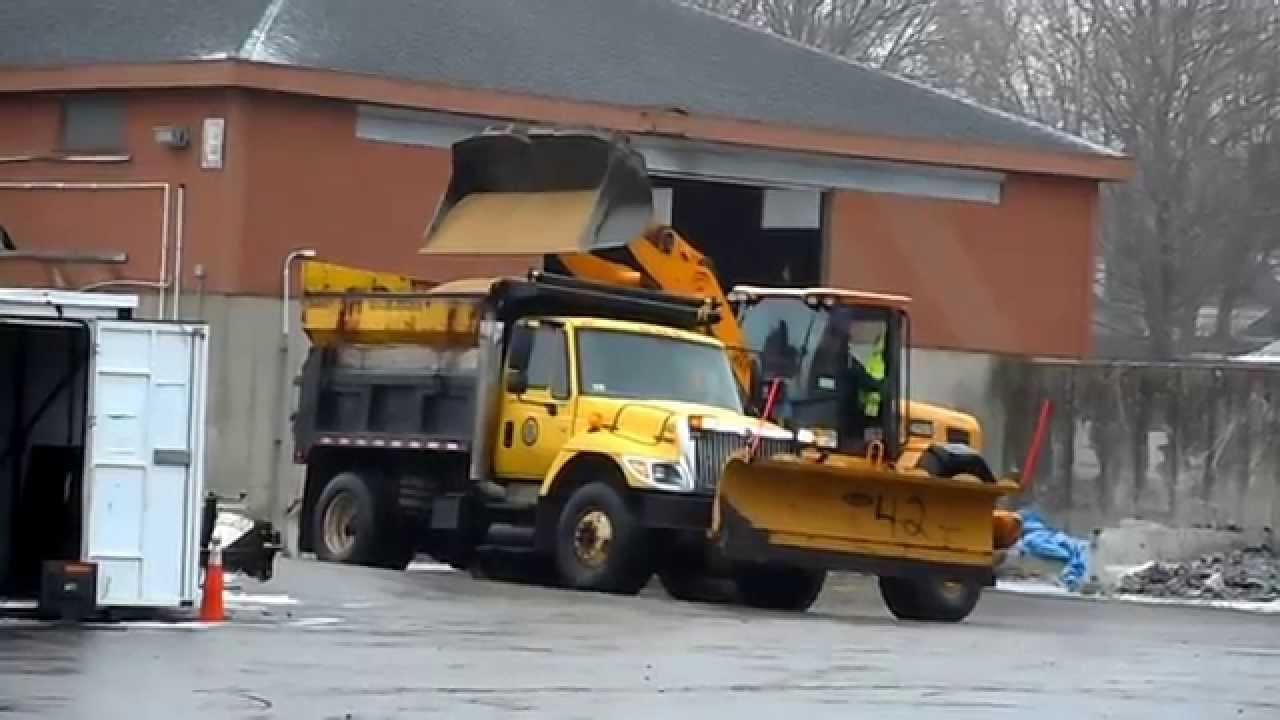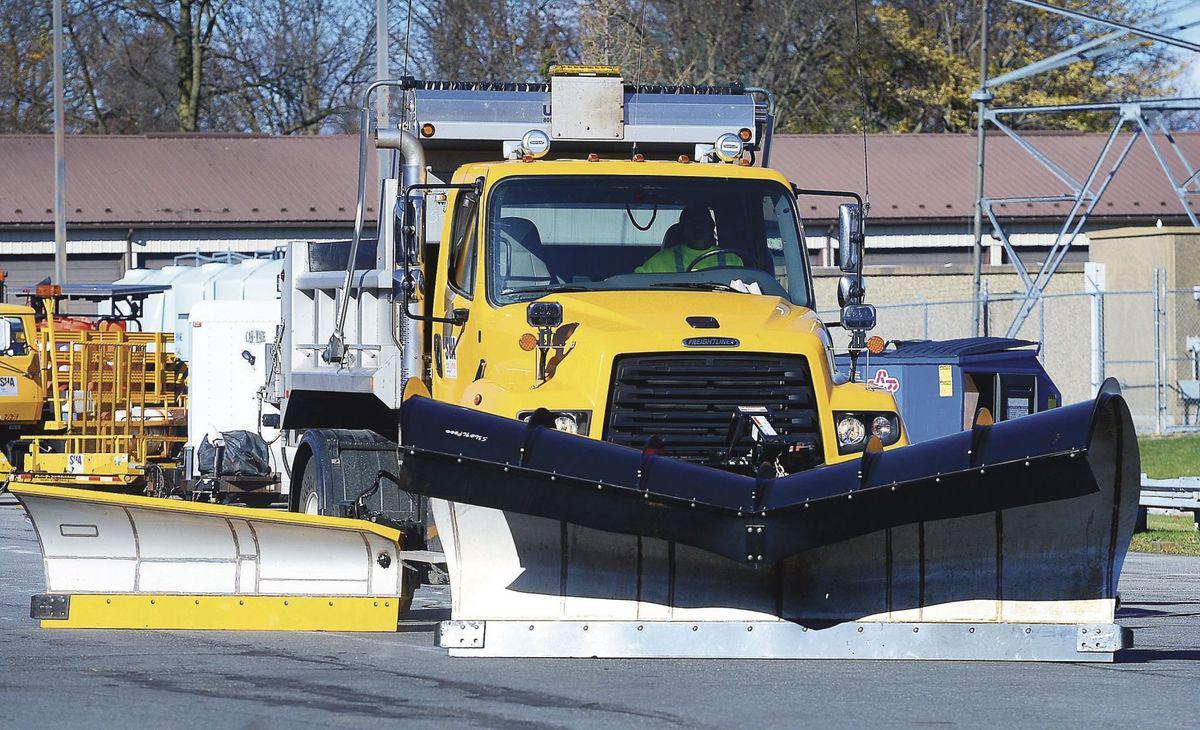The first image is the image on the left, the second image is the image on the right. Examine the images to the left and right. Is the description "The image on the left contains exactly one yellow truck" accurate? Answer yes or no. Yes. 